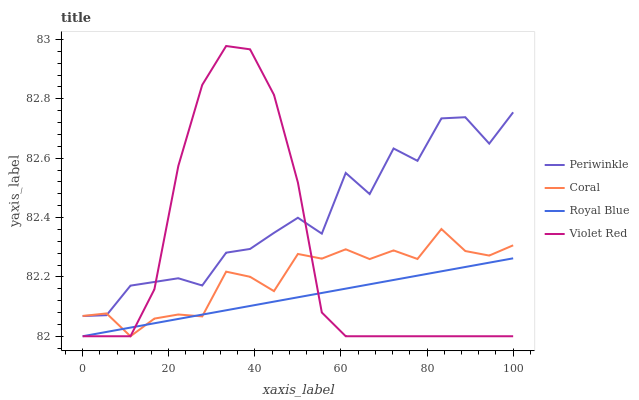Does Royal Blue have the minimum area under the curve?
Answer yes or no. Yes. Does Periwinkle have the maximum area under the curve?
Answer yes or no. Yes. Does Coral have the minimum area under the curve?
Answer yes or no. No. Does Coral have the maximum area under the curve?
Answer yes or no. No. Is Royal Blue the smoothest?
Answer yes or no. Yes. Is Periwinkle the roughest?
Answer yes or no. Yes. Is Coral the smoothest?
Answer yes or no. No. Is Coral the roughest?
Answer yes or no. No. Does Royal Blue have the lowest value?
Answer yes or no. Yes. Does Periwinkle have the lowest value?
Answer yes or no. No. Does Violet Red have the highest value?
Answer yes or no. Yes. Does Coral have the highest value?
Answer yes or no. No. Is Royal Blue less than Periwinkle?
Answer yes or no. Yes. Is Periwinkle greater than Royal Blue?
Answer yes or no. Yes. Does Violet Red intersect Periwinkle?
Answer yes or no. Yes. Is Violet Red less than Periwinkle?
Answer yes or no. No. Is Violet Red greater than Periwinkle?
Answer yes or no. No. Does Royal Blue intersect Periwinkle?
Answer yes or no. No. 